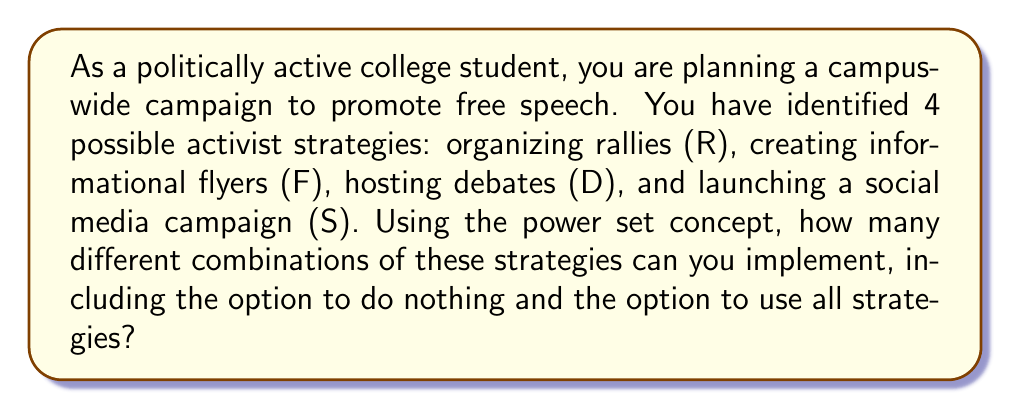Provide a solution to this math problem. Let's approach this step-by-step using set theory and the concept of power sets:

1) First, let's define our set of strategies:
   $A = \{R, F, D, S\}$

2) The power set of A, denoted as $P(A)$, is the set of all possible subsets of A, including the empty set (doing nothing) and A itself (using all strategies).

3) For a set with n elements, the number of elements in its power set is given by $2^n$. This is because for each element, we have two choices: include it or not.

4) In this case, we have 4 elements in our set A. Therefore, the number of elements in the power set will be:

   $|P(A)| = 2^4 = 16$

5) To verify, we can list all possible subsets:
   - $\{\}$ (empty set, doing nothing)
   - $\{R\}, \{F\}, \{D\}, \{S\}$ (single strategies)
   - $\{R,F\}, \{R,D\}, \{R,S\}, \{F,D\}, \{F,S\}, \{D,S\}$ (combinations of two)
   - $\{R,F,D\}, \{R,F,S\}, \{R,D,S\}, \{F,D,S\}$ (combinations of three)
   - $\{R,F,D,S\}$ (all strategies)

Indeed, we can count that there are 16 different subsets in total.

Therefore, there are 16 different combinations of activist strategies you can implement, including doing nothing and using all strategies.
Answer: 16 combinations 